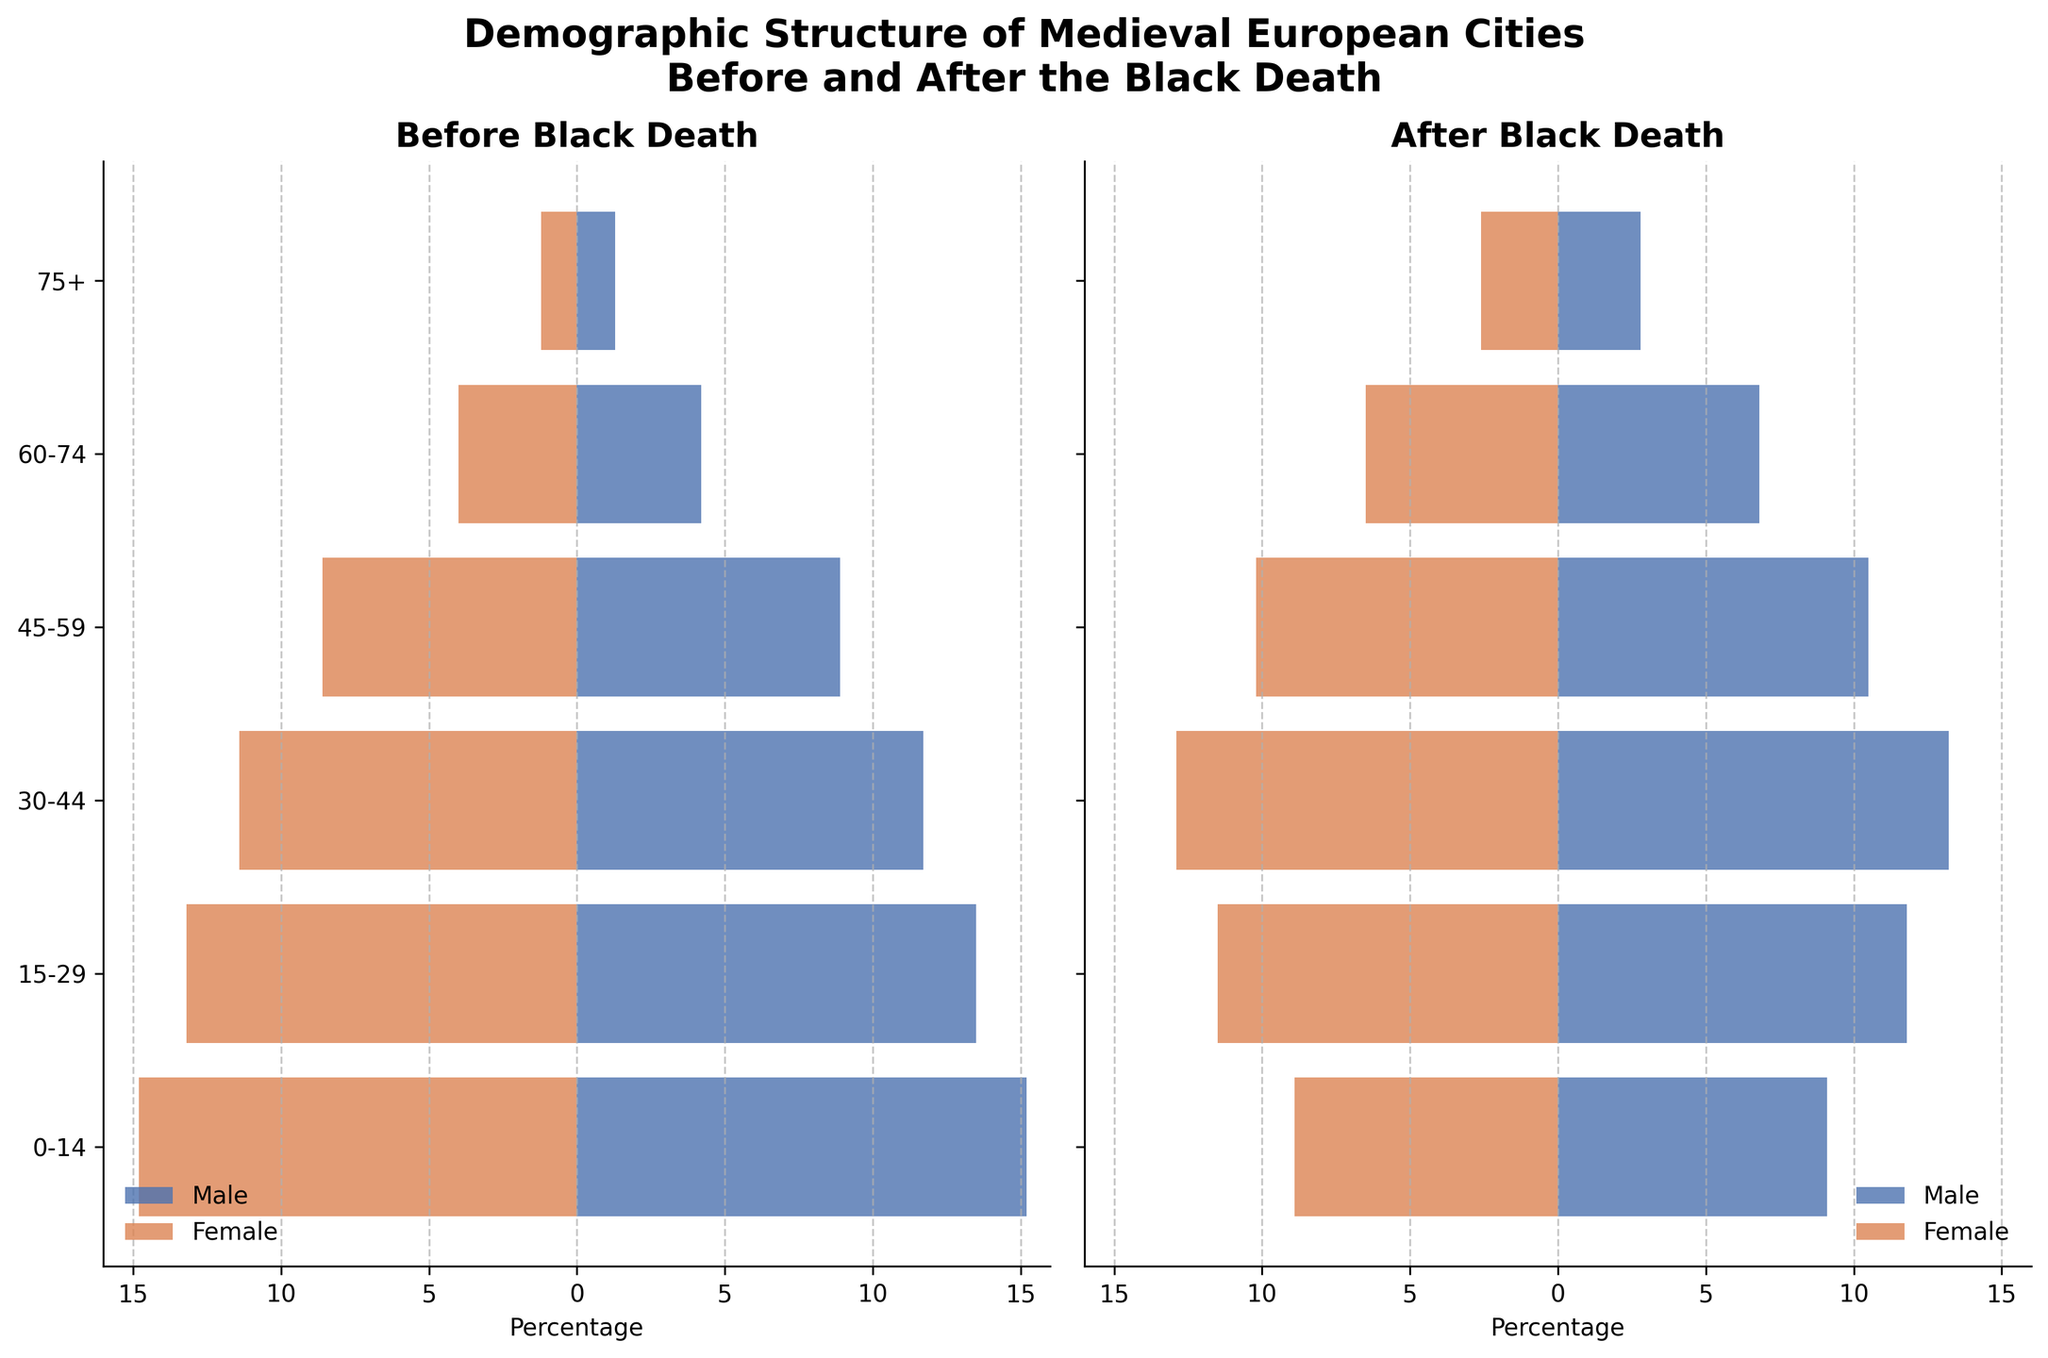What is the title of the figure? The title is a text component located at the top of the figure, providing a description of what the figure represents.
Answer: Demographic Structure of Medieval European Cities Before and After the Black Death Which age group has the highest percentage of males before the Black Death? By observing the "Male Before" bars in the "Before Black Death" plot, look for the longest bar. The '0-14' group has the longest bar in blue.
Answer: 0-14 What is the combined percentage of males and females in the 60-74 age group after the Black Death? Locate the bars for "Male After" and "Female After" in the "60-74" age group. Add the corresponding percentages together: 6.8% (males) + 6.5% (females) = 13.3%.
Answer: 13.3% Which gender and age group saw an increase in their percentage after the Black Death in the 30-44 age range? Compare the bars for males and females in the "30-44" age range before and after the Black Death. "Male After" in this age group increased from 11.7% to 13.2%.
Answer: Males, 30-44 How does the percentage of females aged 75+ after the Black Death compare to before? Look at the bar lengths for "Female Before" and "Female After" in the 75+ section. Notice the increase from 1.2% to 2.6%.
Answer: Increased Which age group experienced the most significant drop in the percentage of children (0-14 years) after the Black Death? Compare the "0-14" age group percentage before and after for both genders. The decrease is from around 15% to around 9% for both males and females.
Answer: 0-14 What trend do you observe in the 45-59 age group when comparing before and after the Black Death? Observe the lengths of the bars for "Male Before" and "Female Before" vs "Male After" and "Female After." Notice that both male and female percentages increased from before to after.
Answer: Increase in both genders Which age group has the smallest difference in the percentage of males and females after the Black Death? Calculate the difference between "Male After" and "Female After" for each age group. The "15-29" age group has the smallest difference, 0.3% (11.8% males - 11.5% females).
Answer: 15-29 What happened to the percentage of males in the 0-14 age group after the Black Death? Look at the "Male Before" and "Male After" bars in the "0-14" age group. The percentage dropped from 15.2% to 9.1%.
Answer: Decreased How do the percentages of males aged 15-29 compare to females of the same age group before the Black Death? Compare the lengths of the bars for "Male Before" and "Female Before" in the "15-29" age group. "Male Before" has 13.5% vs "Female Before" has 13.2%, showing males slightly outnumber females.
Answer: Slightly higher 